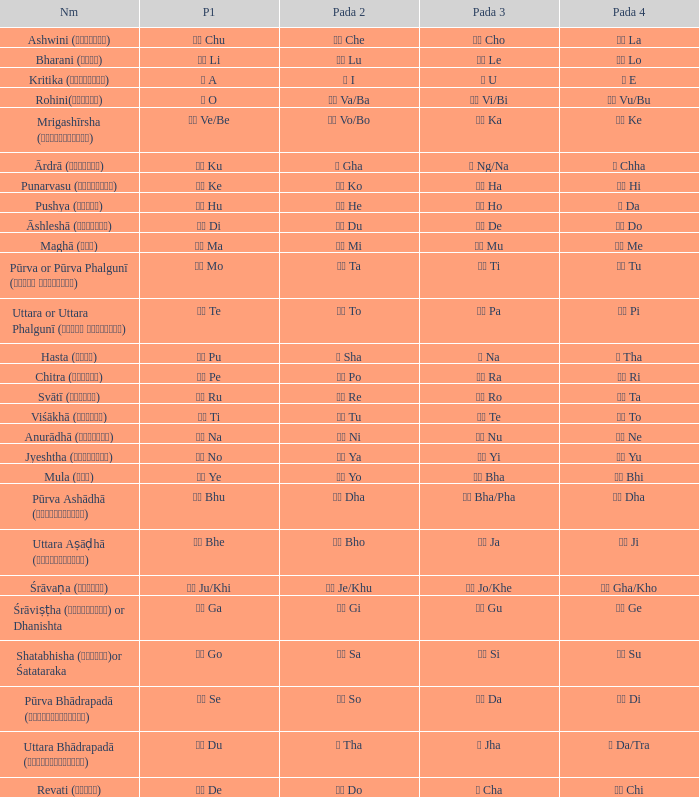Could you help me parse every detail presented in this table? {'header': ['Nm', 'P1', 'Pada 2', 'Pada 3', 'Pada 4'], 'rows': [['Ashwini (अश्विनि)', 'चु Chu', 'चे Che', 'चो Cho', 'ला La'], ['Bharani (भरणी)', 'ली Li', 'लू Lu', 'ले Le', 'लो Lo'], ['Kritika (कृत्तिका)', 'अ A', 'ई I', 'उ U', 'ए E'], ['Rohini(रोहिणी)', 'ओ O', 'वा Va/Ba', 'वी Vi/Bi', 'वु Vu/Bu'], ['Mrigashīrsha (म्रृगशीर्षा)', 'वे Ve/Be', 'वो Vo/Bo', 'का Ka', 'की Ke'], ['Ārdrā (आर्द्रा)', 'कु Ku', 'घ Gha', 'ङ Ng/Na', 'छ Chha'], ['Punarvasu (पुनर्वसु)', 'के Ke', 'को Ko', 'हा Ha', 'ही Hi'], ['Pushya (पुष्य)', 'हु Hu', 'हे He', 'हो Ho', 'ड Da'], ['Āshleshā (आश्लेषा)', 'डी Di', 'डू Du', 'डे De', 'डो Do'], ['Maghā (मघा)', 'मा Ma', 'मी Mi', 'मू Mu', 'मे Me'], ['Pūrva or Pūrva Phalgunī (पूर्व फाल्गुनी)', 'नो Mo', 'टा Ta', 'टी Ti', 'टू Tu'], ['Uttara or Uttara Phalgunī (उत्तर फाल्गुनी)', 'टे Te', 'टो To', 'पा Pa', 'पी Pi'], ['Hasta (हस्त)', 'पू Pu', 'ष Sha', 'ण Na', 'ठ Tha'], ['Chitra (चित्रा)', 'पे Pe', 'पो Po', 'रा Ra', 'री Ri'], ['Svātī (स्वाति)', 'रू Ru', 'रे Re', 'रो Ro', 'ता Ta'], ['Viśākhā (विशाखा)', 'ती Ti', 'तू Tu', 'ते Te', 'तो To'], ['Anurādhā (अनुराधा)', 'ना Na', 'नी Ni', 'नू Nu', 'ने Ne'], ['Jyeshtha (ज्येष्ठा)', 'नो No', 'या Ya', 'यी Yi', 'यू Yu'], ['Mula (मूल)', 'ये Ye', 'यो Yo', 'भा Bha', 'भी Bhi'], ['Pūrva Ashādhā (पूर्वाषाढ़ा)', 'भू Bhu', 'धा Dha', 'फा Bha/Pha', 'ढा Dha'], ['Uttara Aṣāḍhā (उत्तराषाढ़ा)', 'भे Bhe', 'भो Bho', 'जा Ja', 'जी Ji'], ['Śrāvaṇa (श्र\u200cावण)', 'खी Ju/Khi', 'खू Je/Khu', 'खे Jo/Khe', 'खो Gha/Kho'], ['Śrāviṣṭha (श्रविष्ठा) or Dhanishta', 'गा Ga', 'गी Gi', 'गु Gu', 'गे Ge'], ['Shatabhisha (शतभिषा)or Śatataraka', 'गो Go', 'सा Sa', 'सी Si', 'सू Su'], ['Pūrva Bhādrapadā (पूर्वभाद्रपदा)', 'से Se', 'सो So', 'दा Da', 'दी Di'], ['Uttara Bhādrapadā (उत्तरभाद्रपदा)', 'दू Du', 'थ Tha', 'झ Jha', 'ञ Da/Tra'], ['Revati (रेवती)', 'दे De', 'दो Do', 'च Cha', 'ची Chi']]} Which pada 3 has a pada 2 of चे che? चो Cho. 